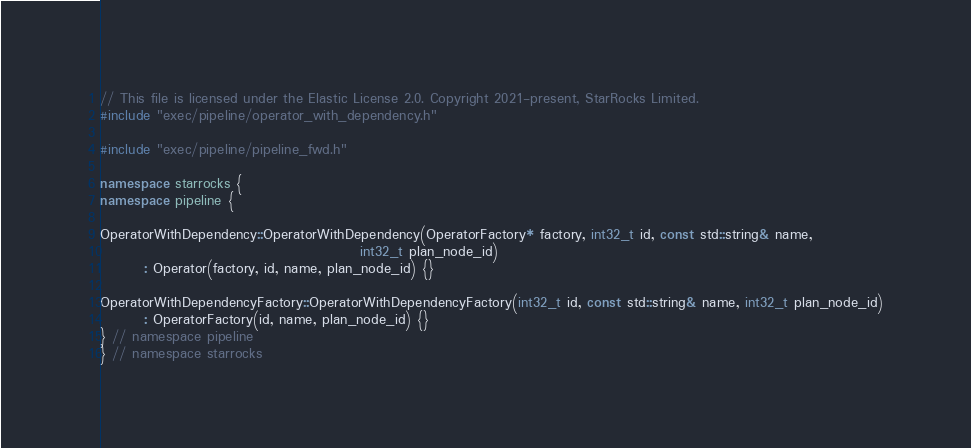<code> <loc_0><loc_0><loc_500><loc_500><_C++_>// This file is licensed under the Elastic License 2.0. Copyright 2021-present, StarRocks Limited.
#include "exec/pipeline/operator_with_dependency.h"

#include "exec/pipeline/pipeline_fwd.h"

namespace starrocks {
namespace pipeline {

OperatorWithDependency::OperatorWithDependency(OperatorFactory* factory, int32_t id, const std::string& name,
                                               int32_t plan_node_id)
        : Operator(factory, id, name, plan_node_id) {}

OperatorWithDependencyFactory::OperatorWithDependencyFactory(int32_t id, const std::string& name, int32_t plan_node_id)
        : OperatorFactory(id, name, plan_node_id) {}
} // namespace pipeline
} // namespace starrocks
</code> 